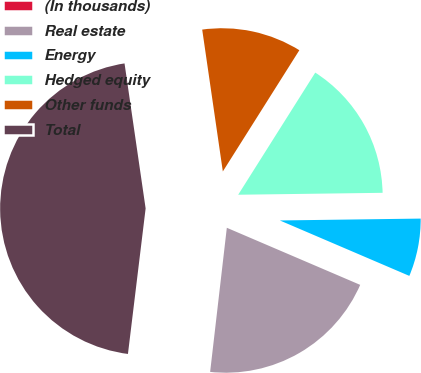<chart> <loc_0><loc_0><loc_500><loc_500><pie_chart><fcel>(In thousands)<fcel>Real estate<fcel>Energy<fcel>Hedged equity<fcel>Other funds<fcel>Total<nl><fcel>0.09%<fcel>20.4%<fcel>6.65%<fcel>15.83%<fcel>11.26%<fcel>45.78%<nl></chart> 